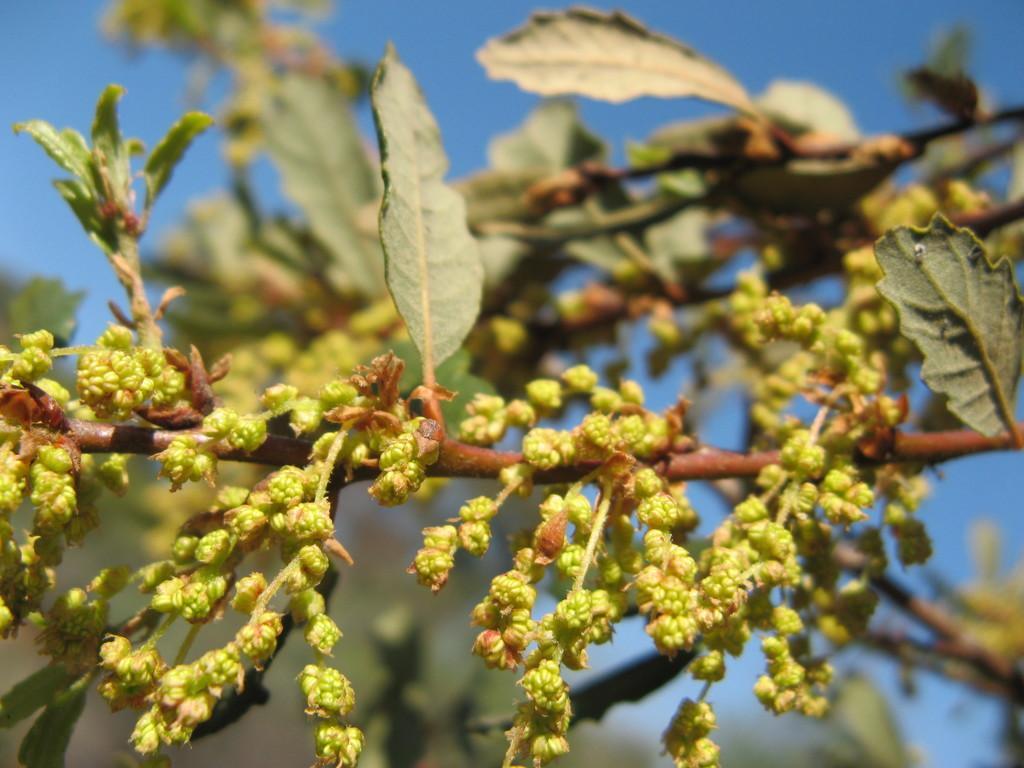Please provide a concise description of this image. In this picture we can see buds and leaves and in the background we can see the sky. 